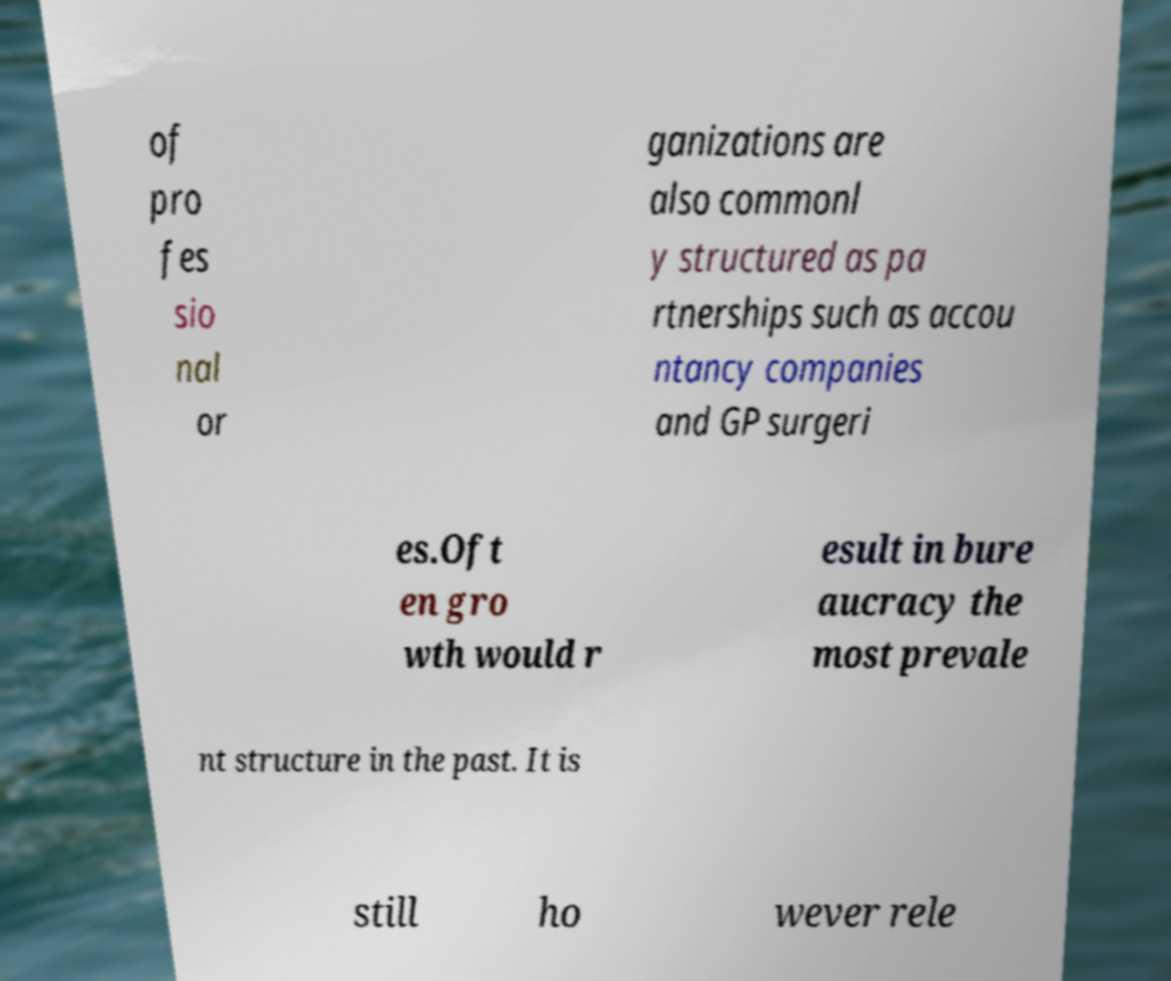Can you read and provide the text displayed in the image?This photo seems to have some interesting text. Can you extract and type it out for me? of pro fes sio nal or ganizations are also commonl y structured as pa rtnerships such as accou ntancy companies and GP surgeri es.Oft en gro wth would r esult in bure aucracy the most prevale nt structure in the past. It is still ho wever rele 